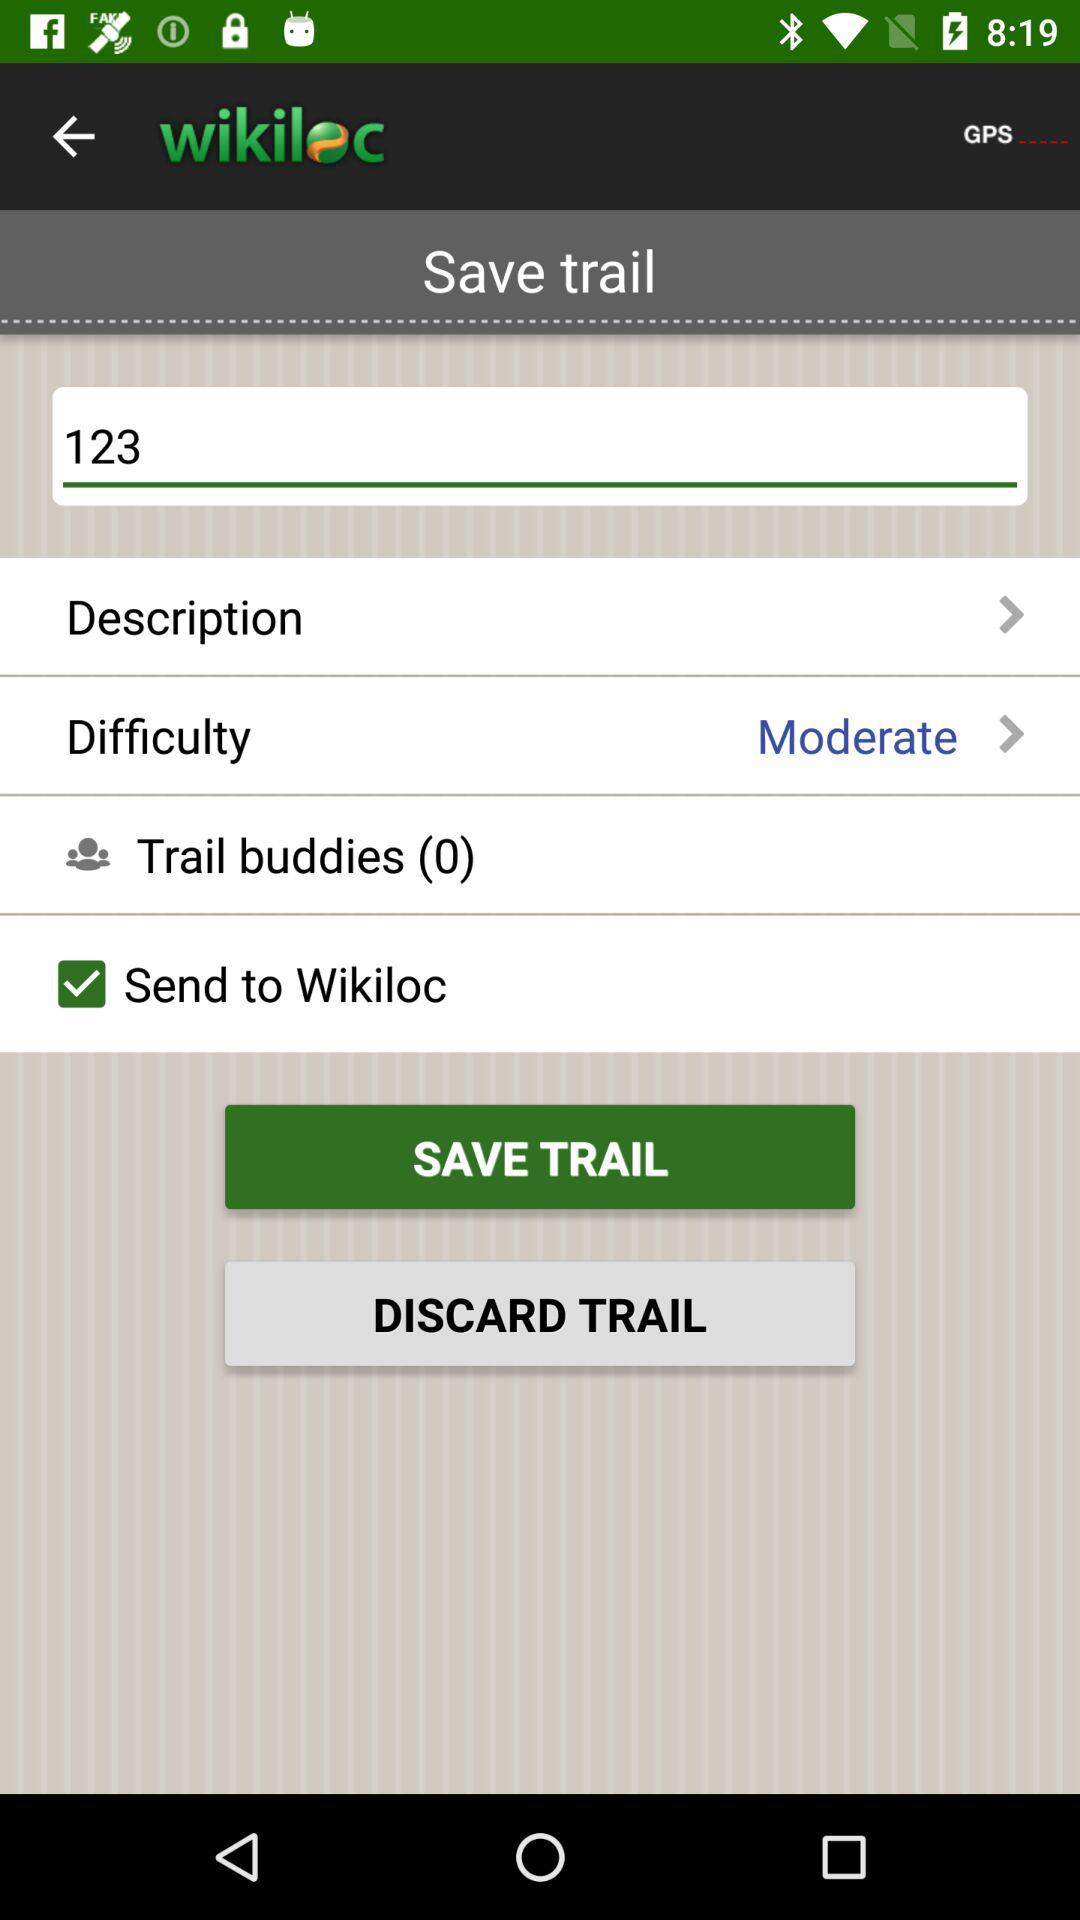Which option is marked as checked? The option that is marked as checked is "Send to Wikiloc". 